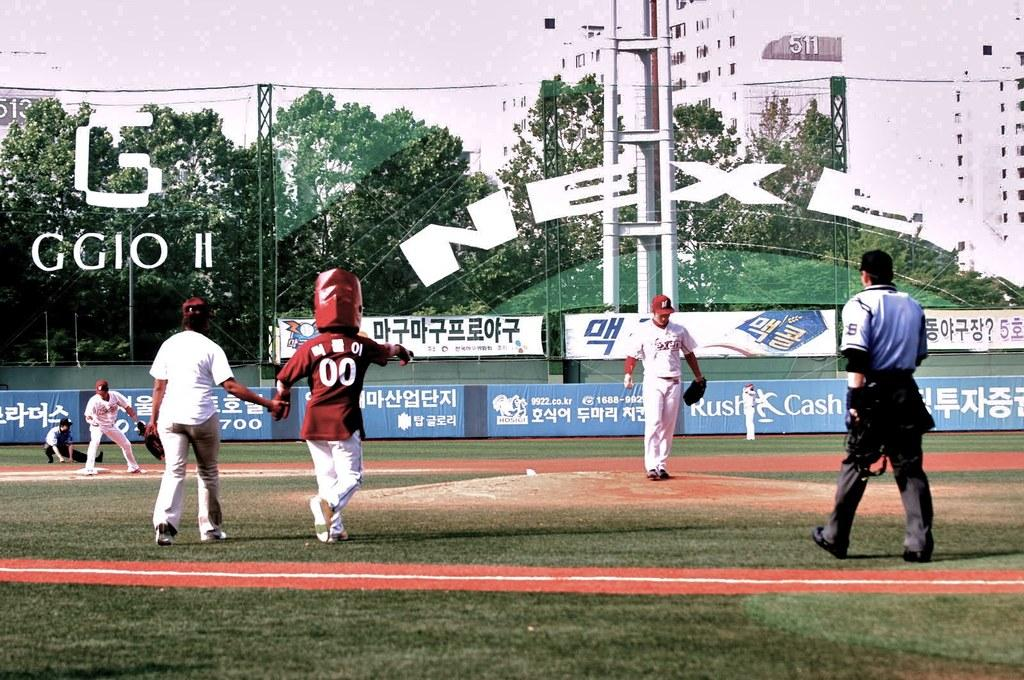<image>
Give a short and clear explanation of the subsequent image. An ad for Rush Cash can be seen on a baseball field. 